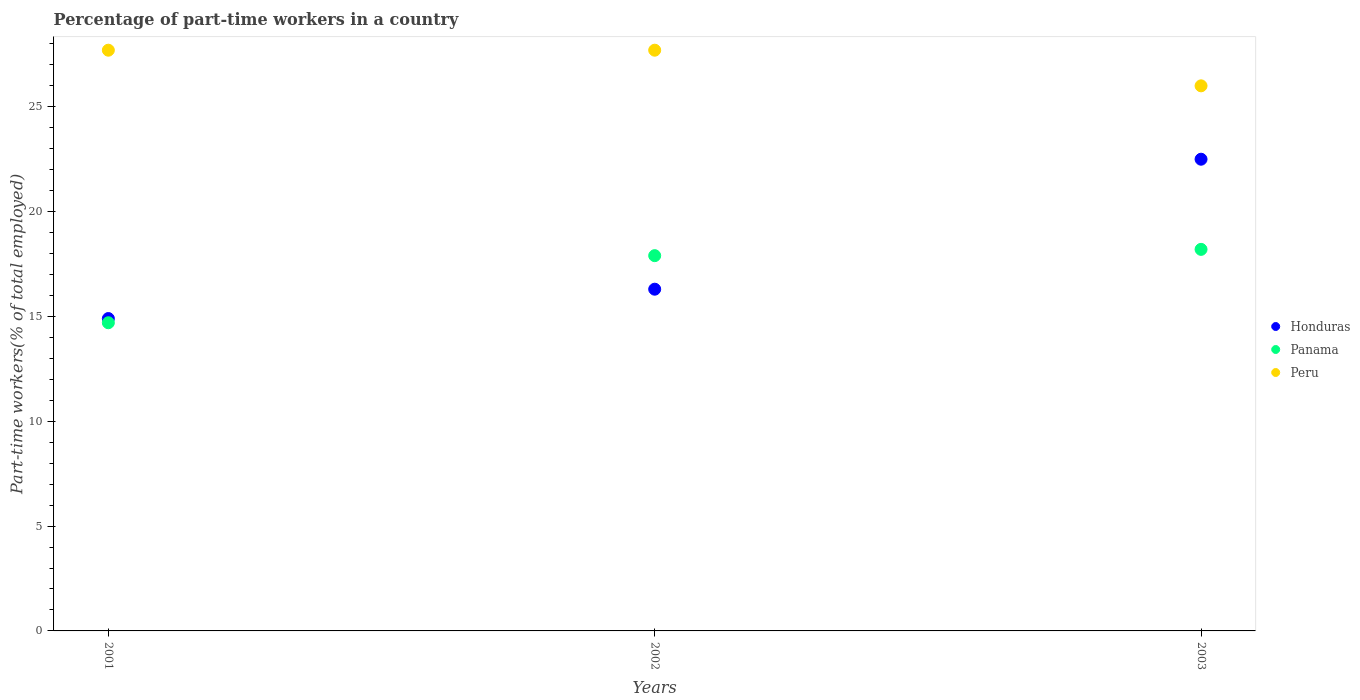How many different coloured dotlines are there?
Offer a very short reply. 3. What is the percentage of part-time workers in Peru in 2002?
Provide a short and direct response. 27.7. Across all years, what is the maximum percentage of part-time workers in Peru?
Provide a short and direct response. 27.7. Across all years, what is the minimum percentage of part-time workers in Panama?
Offer a terse response. 14.7. In which year was the percentage of part-time workers in Peru maximum?
Offer a very short reply. 2001. In which year was the percentage of part-time workers in Honduras minimum?
Give a very brief answer. 2001. What is the total percentage of part-time workers in Honduras in the graph?
Offer a very short reply. 53.7. What is the difference between the percentage of part-time workers in Honduras in 2001 and that in 2002?
Ensure brevity in your answer.  -1.4. What is the difference between the percentage of part-time workers in Panama in 2002 and the percentage of part-time workers in Honduras in 2003?
Ensure brevity in your answer.  -4.6. What is the average percentage of part-time workers in Peru per year?
Ensure brevity in your answer.  27.13. In the year 2001, what is the difference between the percentage of part-time workers in Honduras and percentage of part-time workers in Peru?
Your answer should be very brief. -12.8. In how many years, is the percentage of part-time workers in Peru greater than 6 %?
Ensure brevity in your answer.  3. What is the ratio of the percentage of part-time workers in Peru in 2002 to that in 2003?
Your answer should be very brief. 1.07. Is the difference between the percentage of part-time workers in Honduras in 2001 and 2002 greater than the difference between the percentage of part-time workers in Peru in 2001 and 2002?
Ensure brevity in your answer.  No. What is the difference between the highest and the lowest percentage of part-time workers in Panama?
Make the answer very short. 3.5. In how many years, is the percentage of part-time workers in Honduras greater than the average percentage of part-time workers in Honduras taken over all years?
Provide a short and direct response. 1. Is the sum of the percentage of part-time workers in Peru in 2001 and 2002 greater than the maximum percentage of part-time workers in Panama across all years?
Offer a terse response. Yes. Is it the case that in every year, the sum of the percentage of part-time workers in Peru and percentage of part-time workers in Panama  is greater than the percentage of part-time workers in Honduras?
Provide a short and direct response. Yes. Does the percentage of part-time workers in Panama monotonically increase over the years?
Provide a short and direct response. Yes. Is the percentage of part-time workers in Peru strictly less than the percentage of part-time workers in Panama over the years?
Offer a terse response. No. What is the difference between two consecutive major ticks on the Y-axis?
Give a very brief answer. 5. Are the values on the major ticks of Y-axis written in scientific E-notation?
Offer a very short reply. No. Does the graph contain grids?
Offer a very short reply. No. How many legend labels are there?
Provide a short and direct response. 3. How are the legend labels stacked?
Your response must be concise. Vertical. What is the title of the graph?
Your answer should be compact. Percentage of part-time workers in a country. Does "Mauritania" appear as one of the legend labels in the graph?
Offer a very short reply. No. What is the label or title of the Y-axis?
Give a very brief answer. Part-time workers(% of total employed). What is the Part-time workers(% of total employed) in Honduras in 2001?
Your response must be concise. 14.9. What is the Part-time workers(% of total employed) of Panama in 2001?
Ensure brevity in your answer.  14.7. What is the Part-time workers(% of total employed) in Peru in 2001?
Provide a succinct answer. 27.7. What is the Part-time workers(% of total employed) of Honduras in 2002?
Your answer should be compact. 16.3. What is the Part-time workers(% of total employed) in Panama in 2002?
Your answer should be very brief. 17.9. What is the Part-time workers(% of total employed) of Peru in 2002?
Your answer should be compact. 27.7. What is the Part-time workers(% of total employed) in Panama in 2003?
Your response must be concise. 18.2. Across all years, what is the maximum Part-time workers(% of total employed) of Honduras?
Offer a very short reply. 22.5. Across all years, what is the maximum Part-time workers(% of total employed) in Panama?
Make the answer very short. 18.2. Across all years, what is the maximum Part-time workers(% of total employed) in Peru?
Keep it short and to the point. 27.7. Across all years, what is the minimum Part-time workers(% of total employed) of Honduras?
Keep it short and to the point. 14.9. Across all years, what is the minimum Part-time workers(% of total employed) of Panama?
Your response must be concise. 14.7. What is the total Part-time workers(% of total employed) in Honduras in the graph?
Your answer should be very brief. 53.7. What is the total Part-time workers(% of total employed) of Panama in the graph?
Provide a succinct answer. 50.8. What is the total Part-time workers(% of total employed) in Peru in the graph?
Your answer should be very brief. 81.4. What is the difference between the Part-time workers(% of total employed) of Honduras in 2001 and that in 2002?
Make the answer very short. -1.4. What is the difference between the Part-time workers(% of total employed) in Panama in 2001 and that in 2002?
Your answer should be very brief. -3.2. What is the difference between the Part-time workers(% of total employed) in Peru in 2001 and that in 2002?
Offer a terse response. 0. What is the difference between the Part-time workers(% of total employed) of Panama in 2001 and that in 2003?
Provide a short and direct response. -3.5. What is the difference between the Part-time workers(% of total employed) of Peru in 2001 and that in 2003?
Your answer should be compact. 1.7. What is the difference between the Part-time workers(% of total employed) in Panama in 2002 and that in 2003?
Ensure brevity in your answer.  -0.3. What is the difference between the Part-time workers(% of total employed) in Honduras in 2001 and the Part-time workers(% of total employed) in Peru in 2002?
Your response must be concise. -12.8. What is the difference between the Part-time workers(% of total employed) of Honduras in 2001 and the Part-time workers(% of total employed) of Panama in 2003?
Offer a terse response. -3.3. What is the difference between the Part-time workers(% of total employed) of Honduras in 2001 and the Part-time workers(% of total employed) of Peru in 2003?
Make the answer very short. -11.1. What is the difference between the Part-time workers(% of total employed) in Panama in 2002 and the Part-time workers(% of total employed) in Peru in 2003?
Provide a succinct answer. -8.1. What is the average Part-time workers(% of total employed) in Honduras per year?
Provide a short and direct response. 17.9. What is the average Part-time workers(% of total employed) of Panama per year?
Offer a very short reply. 16.93. What is the average Part-time workers(% of total employed) of Peru per year?
Offer a terse response. 27.13. In the year 2001, what is the difference between the Part-time workers(% of total employed) in Honduras and Part-time workers(% of total employed) in Panama?
Your response must be concise. 0.2. In the year 2001, what is the difference between the Part-time workers(% of total employed) in Panama and Part-time workers(% of total employed) in Peru?
Your response must be concise. -13. In the year 2002, what is the difference between the Part-time workers(% of total employed) of Honduras and Part-time workers(% of total employed) of Panama?
Offer a terse response. -1.6. In the year 2002, what is the difference between the Part-time workers(% of total employed) in Honduras and Part-time workers(% of total employed) in Peru?
Offer a terse response. -11.4. In the year 2002, what is the difference between the Part-time workers(% of total employed) of Panama and Part-time workers(% of total employed) of Peru?
Provide a succinct answer. -9.8. In the year 2003, what is the difference between the Part-time workers(% of total employed) of Honduras and Part-time workers(% of total employed) of Panama?
Your response must be concise. 4.3. In the year 2003, what is the difference between the Part-time workers(% of total employed) in Honduras and Part-time workers(% of total employed) in Peru?
Offer a very short reply. -3.5. In the year 2003, what is the difference between the Part-time workers(% of total employed) in Panama and Part-time workers(% of total employed) in Peru?
Your answer should be very brief. -7.8. What is the ratio of the Part-time workers(% of total employed) in Honduras in 2001 to that in 2002?
Your answer should be very brief. 0.91. What is the ratio of the Part-time workers(% of total employed) of Panama in 2001 to that in 2002?
Your response must be concise. 0.82. What is the ratio of the Part-time workers(% of total employed) in Peru in 2001 to that in 2002?
Your answer should be very brief. 1. What is the ratio of the Part-time workers(% of total employed) of Honduras in 2001 to that in 2003?
Your answer should be compact. 0.66. What is the ratio of the Part-time workers(% of total employed) in Panama in 2001 to that in 2003?
Give a very brief answer. 0.81. What is the ratio of the Part-time workers(% of total employed) of Peru in 2001 to that in 2003?
Your answer should be very brief. 1.07. What is the ratio of the Part-time workers(% of total employed) in Honduras in 2002 to that in 2003?
Your answer should be very brief. 0.72. What is the ratio of the Part-time workers(% of total employed) of Panama in 2002 to that in 2003?
Keep it short and to the point. 0.98. What is the ratio of the Part-time workers(% of total employed) of Peru in 2002 to that in 2003?
Ensure brevity in your answer.  1.07. What is the difference between the highest and the second highest Part-time workers(% of total employed) in Honduras?
Provide a succinct answer. 6.2. What is the difference between the highest and the lowest Part-time workers(% of total employed) of Panama?
Give a very brief answer. 3.5. What is the difference between the highest and the lowest Part-time workers(% of total employed) of Peru?
Make the answer very short. 1.7. 